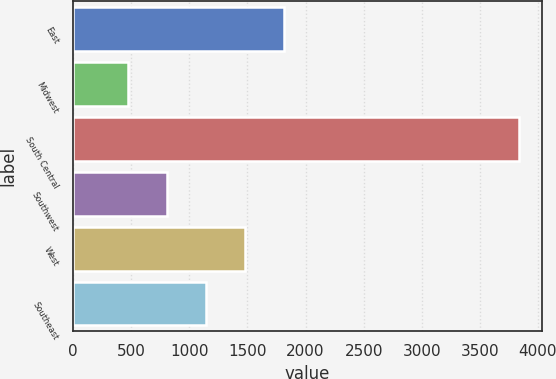<chart> <loc_0><loc_0><loc_500><loc_500><bar_chart><fcel>East<fcel>Midwest<fcel>South Central<fcel>Southwest<fcel>West<fcel>Southeast<nl><fcel>1818<fcel>470<fcel>3840<fcel>807<fcel>1481<fcel>1144<nl></chart> 